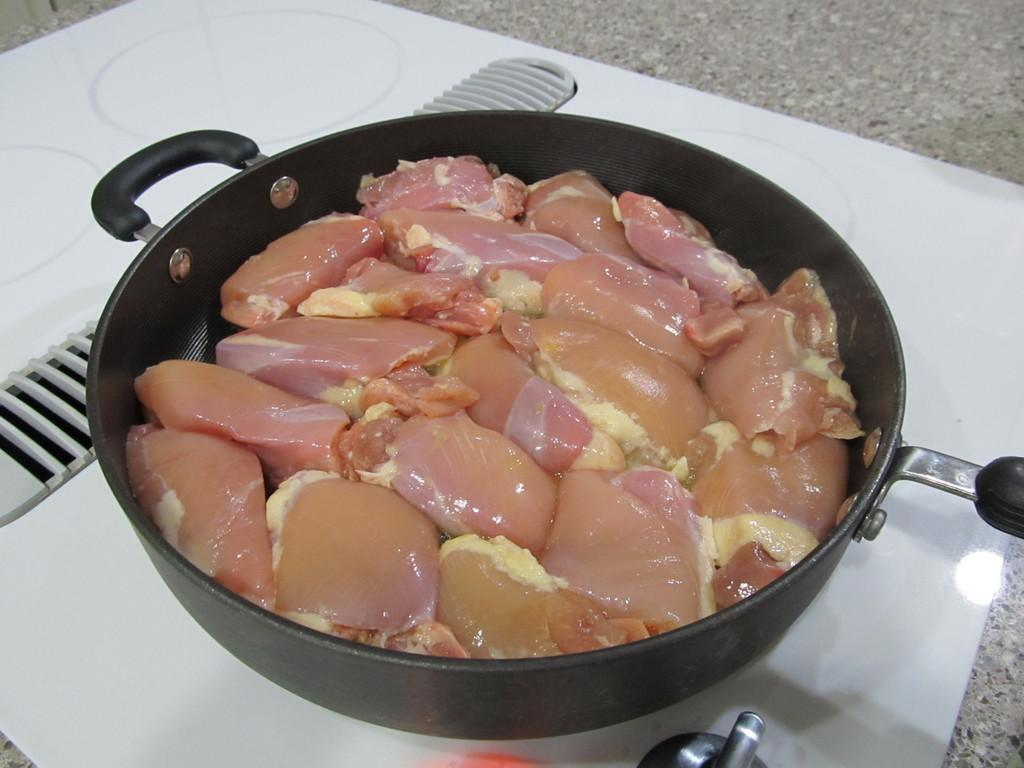What type of food is visible in the image? There is raw meat in the image. How is the raw meat contained in the image? The raw meat is in a vessel. Where is the vessel with raw meat located? The vessel is placed on a cabinet. What type of caption is written on the raw meat in the image? There is no caption written on the raw meat in the image. Can you see any pickles or balloons in the image? There are no pickles or balloons present in the image. 